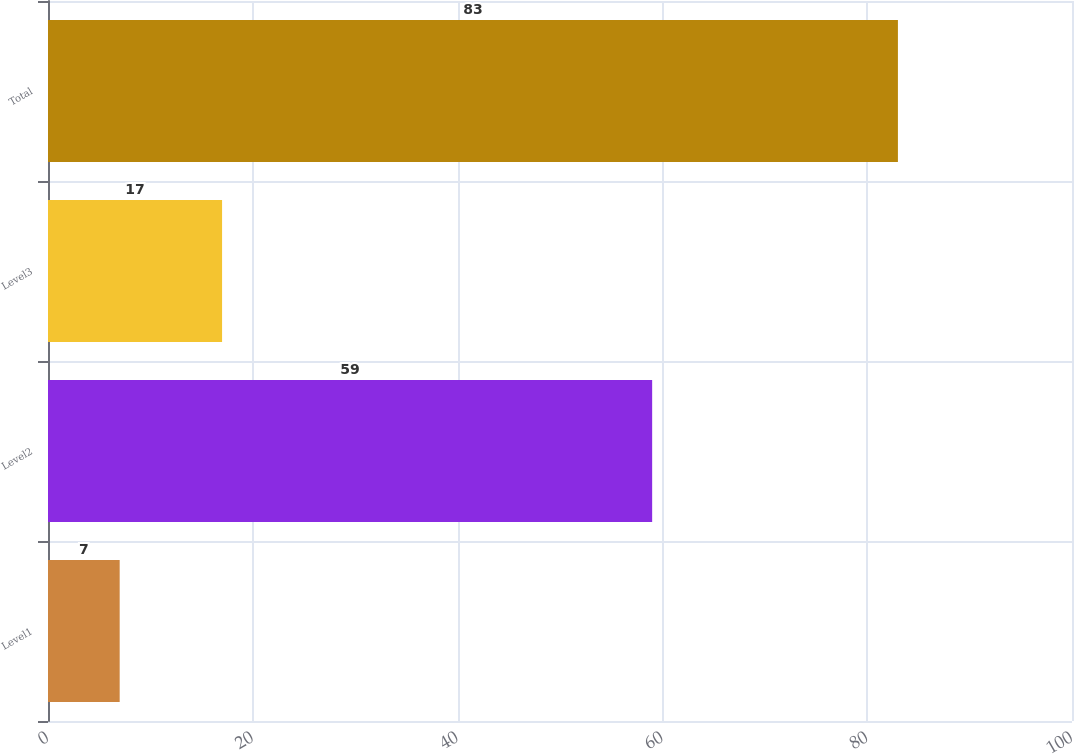Convert chart to OTSL. <chart><loc_0><loc_0><loc_500><loc_500><bar_chart><fcel>Level1<fcel>Level2<fcel>Level3<fcel>Total<nl><fcel>7<fcel>59<fcel>17<fcel>83<nl></chart> 